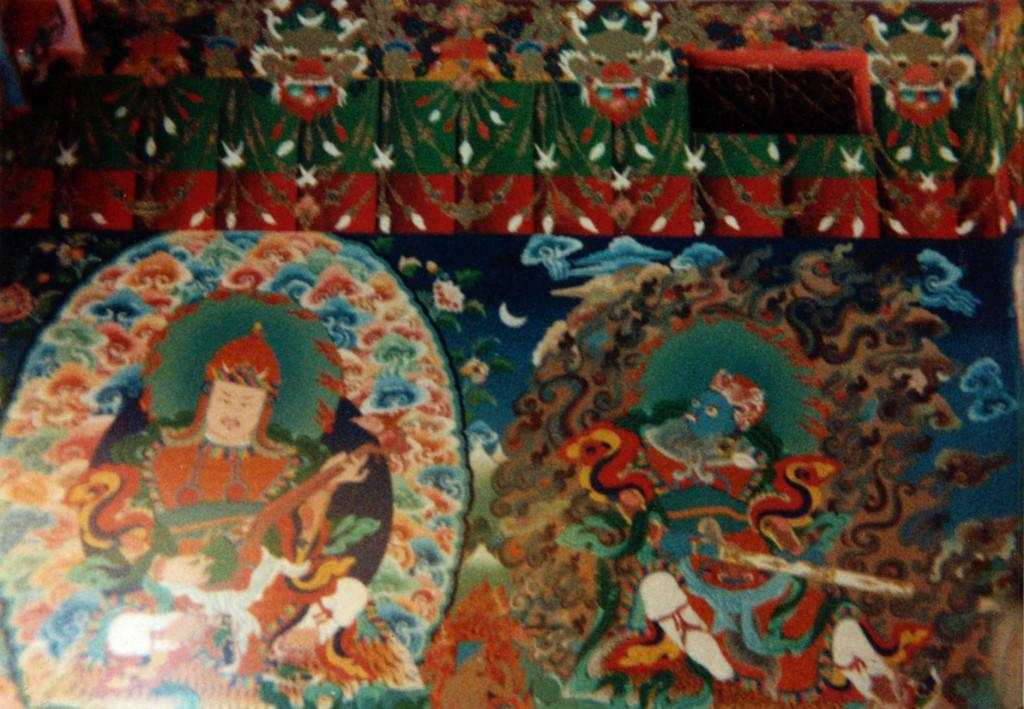What is the main subject of the image? The main subject of the image is an art design. What is included in the art design? The art design includes a person and other things. What type of pie is being served in the image? There is no pie present in the image; it features an art design with a person and other things. How many matches are visible in the image? There are no matches present in the image; it features an art design with a person and other things. 